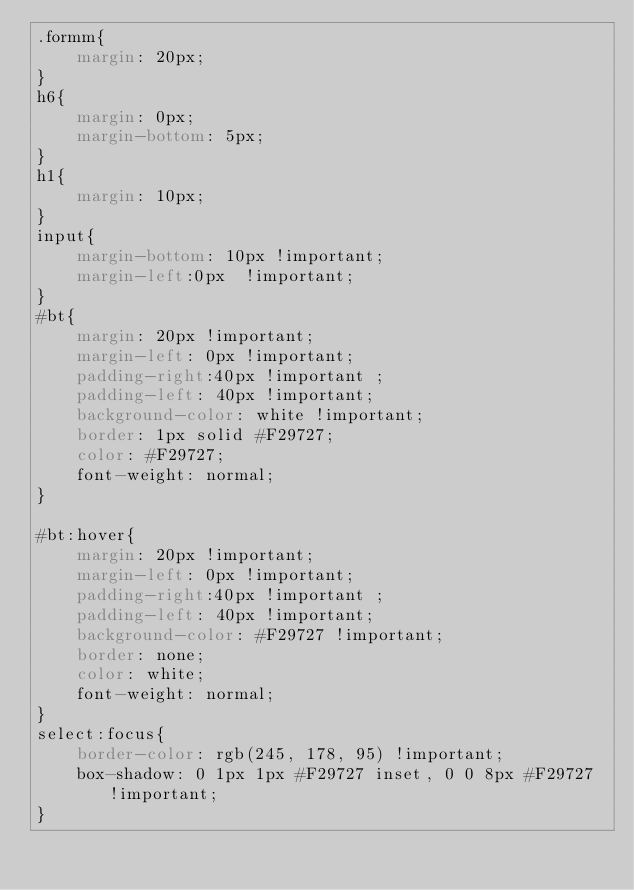Convert code to text. <code><loc_0><loc_0><loc_500><loc_500><_CSS_>.formm{
    margin: 20px;
}
h6{
    margin: 0px;
    margin-bottom: 5px;
}
h1{
    margin: 10px;
}
input{
    margin-bottom: 10px !important;
    margin-left:0px  !important;
}
#bt{
    margin: 20px !important;
    margin-left: 0px !important;
    padding-right:40px !important ;
    padding-left: 40px !important;
    background-color: white !important;
    border: 1px solid #F29727;
    color: #F29727;
    font-weight: normal;
}

#bt:hover{
    margin: 20px !important;
    margin-left: 0px !important;
    padding-right:40px !important ;
    padding-left: 40px !important;
    background-color: #F29727 !important;
    border: none;
    color: white;
    font-weight: normal;
}
select:focus{
    border-color: rgb(245, 178, 95) !important;
    box-shadow: 0 1px 1px #F29727 inset, 0 0 8px #F29727 !important;
}</code> 